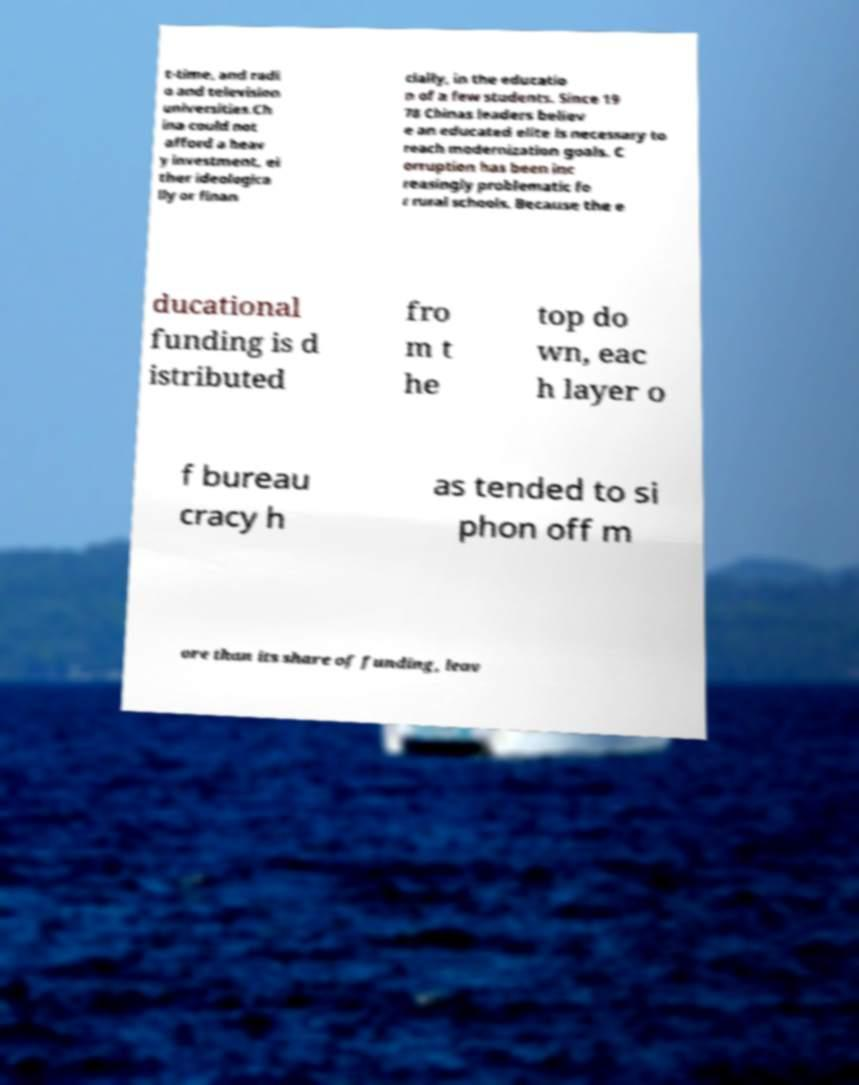Can you accurately transcribe the text from the provided image for me? t-time, and radi o and television universities.Ch ina could not afford a heav y investment, ei ther ideologica lly or finan cially, in the educatio n of a few students. Since 19 78 Chinas leaders believ e an educated elite is necessary to reach modernization goals. C orruption has been inc reasingly problematic fo r rural schools. Because the e ducational funding is d istributed fro m t he top do wn, eac h layer o f bureau cracy h as tended to si phon off m ore than its share of funding, leav 